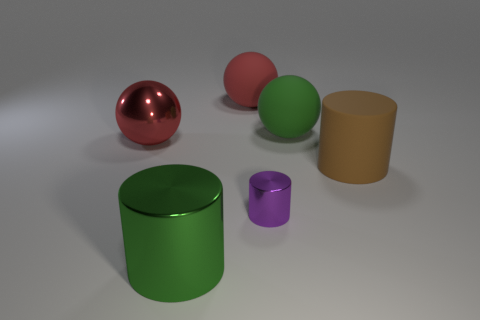Are there any other things that have the same size as the purple thing?
Provide a succinct answer. No. What is the color of the rubber ball left of the tiny shiny cylinder?
Your answer should be very brief. Red. How many other things are made of the same material as the large brown cylinder?
Keep it short and to the point. 2. Are there more brown objects left of the matte cylinder than big brown cylinders that are left of the red rubber ball?
Your answer should be compact. No. How many large red metal things are on the left side of the green cylinder?
Make the answer very short. 1. Is the big brown thing made of the same material as the big red sphere that is behind the red shiny ball?
Keep it short and to the point. Yes. Are there any other things that are the same shape as the purple object?
Your answer should be compact. Yes. Is the small purple cylinder made of the same material as the green cylinder?
Provide a short and direct response. Yes. There is a tiny purple shiny thing that is right of the green metallic object; are there any large green shiny cylinders on the left side of it?
Keep it short and to the point. Yes. How many large objects are in front of the green matte sphere and to the left of the brown thing?
Offer a terse response. 2. 